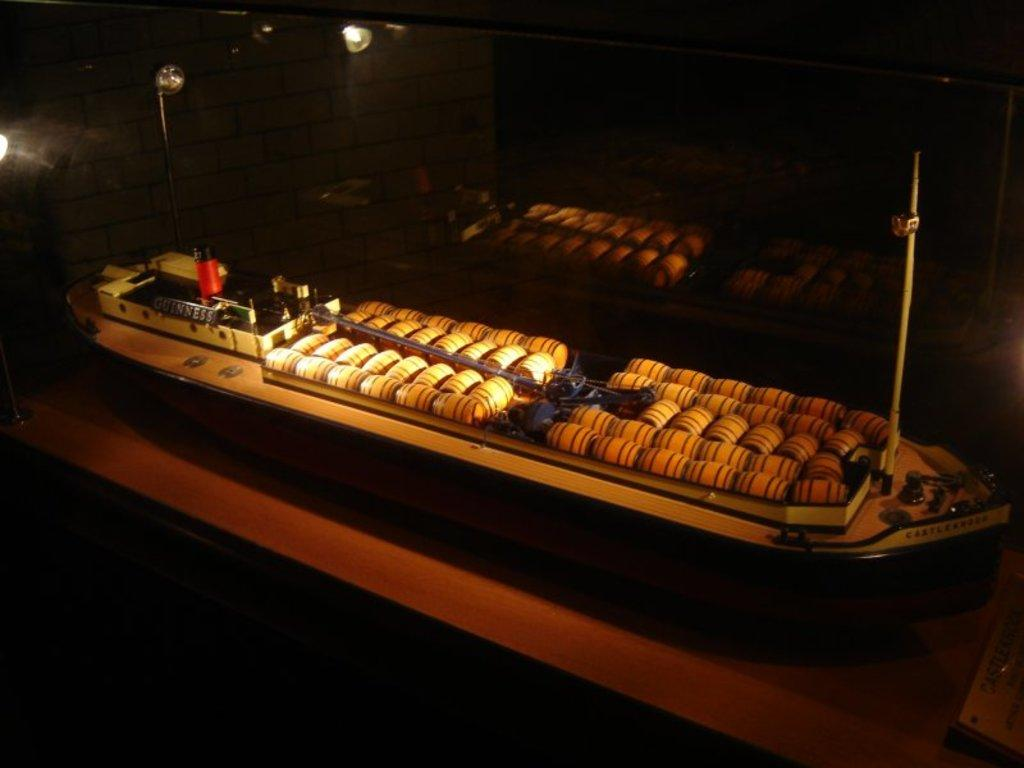What is the main object in the image? There is a ship toy in the image. Where is the ship toy located? The ship toy is placed on a table. What can be seen in the background of the image? There are lights in the background of the image. What piece of furniture is present in the image? There is a table in the image. What type of arm is holding the ship toy in the image? There is no arm present in the image; the ship toy is placed on a table. How many buns are visible on the ship toy in the image? There are no buns present on the ship toy in the image. 